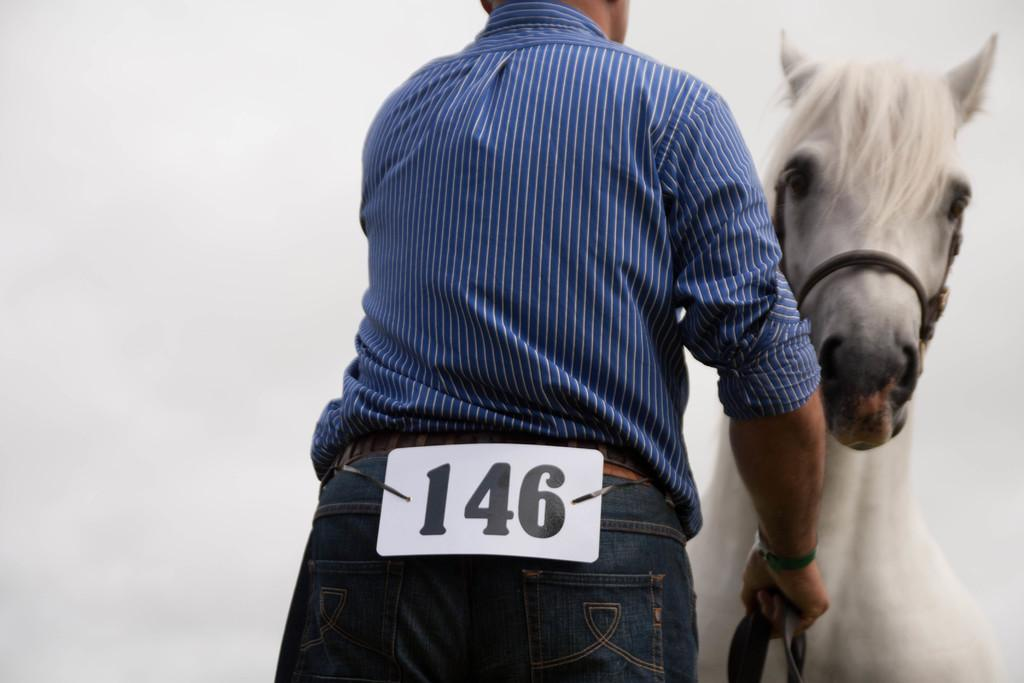Who is present in the image? There is a man in the image. What is the man holding in the image? The man is holding a horse. What type of lock can be seen on the horse's saddle in the image? There is no lock present on the horse's saddle in the image. 